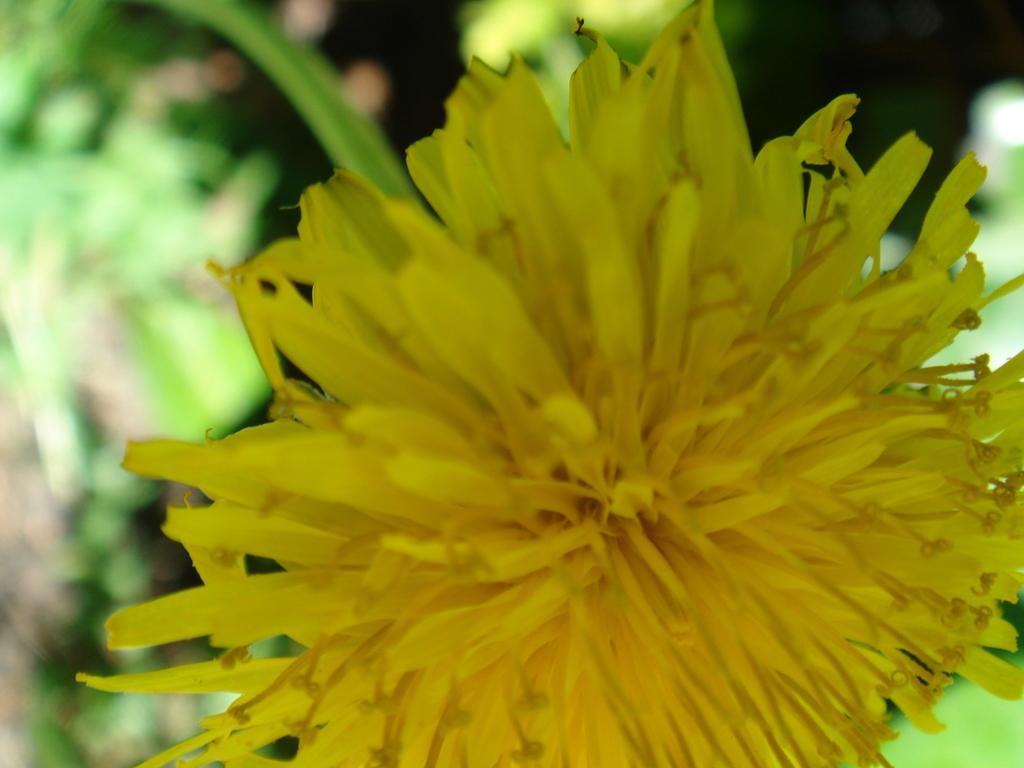What is the main subject in the foreground of the image? There is a flower in the foreground of the image. What can be observed about the background of the image? The background of the image is blurred. What degree does the apple have in the image? There is no apple present in the image, so it is not possible to determine the degree of an apple. 